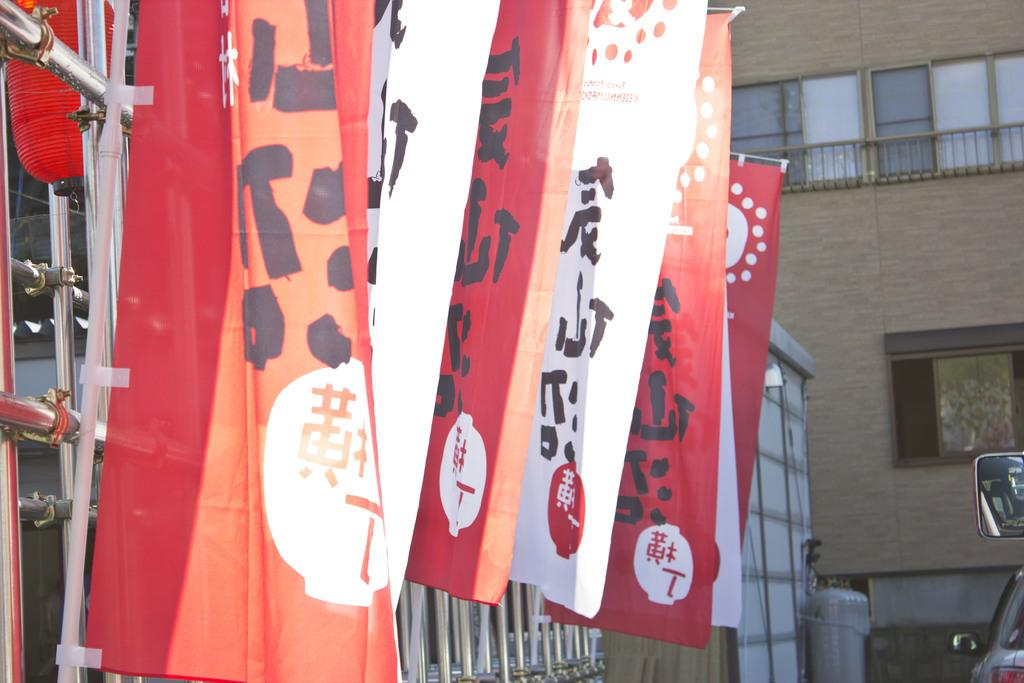What objects can be seen in the image that are made of wood or a similar material? There are boards in the image. What objects in the image are used for signaling or representing a group or country? There are flags in the image. What type of material is used to support the flags and boards in the image? There are metal rods in the image. What type of transportation is visible on the road in the image? There are vehicles on the road in the image. What type of structures can be seen in the background of the image? There are buildings in the image. Can you determine the time of day when the image was taken? Yes, the image was taken during the day. What type of alarm can be heard going off in the image? There is no alarm present in the image, and therefore no sound can be heard. What type of magic is being performed in the image? There is no magic or magical elements present in the image. 